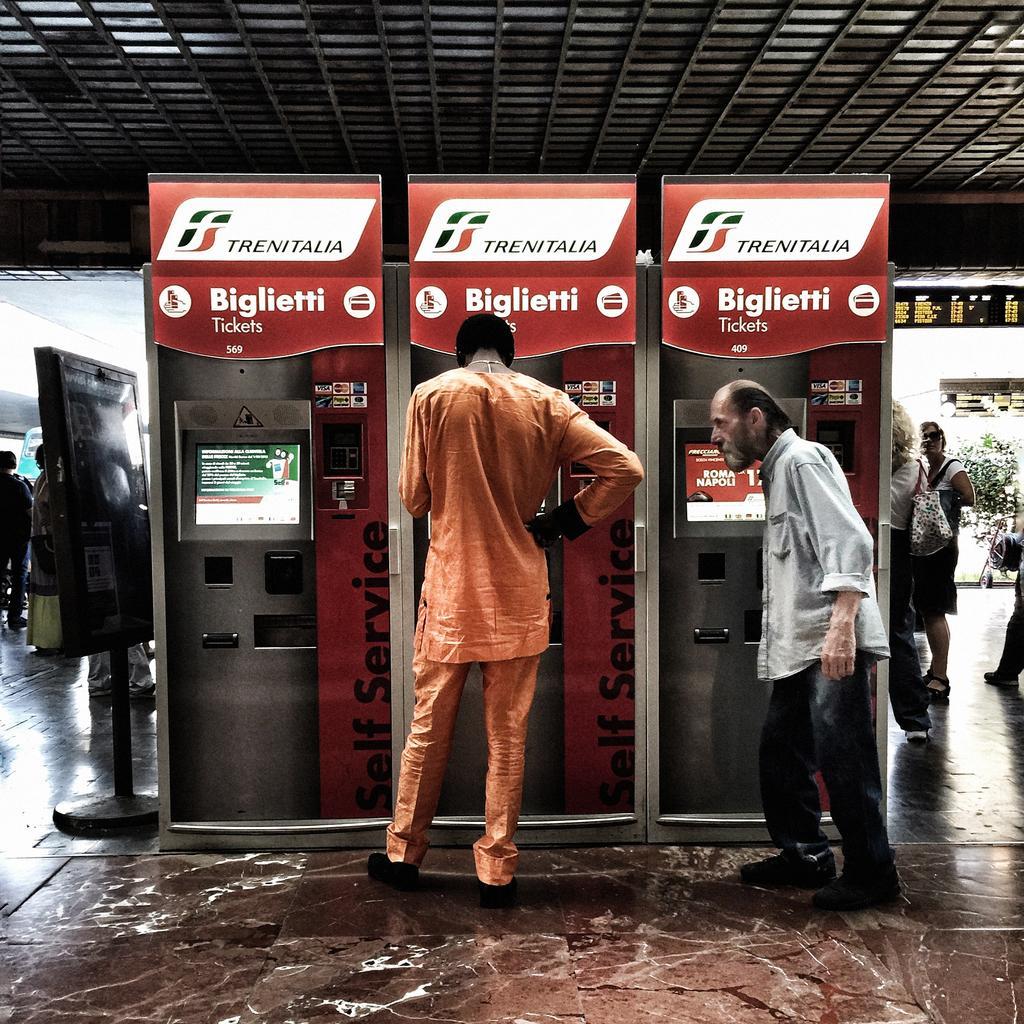Please provide a concise description of this image. In this image we can see persons standing near the ticket counters. In the background we can see roof, plants, persons standing on the floor, information boards and floor. 